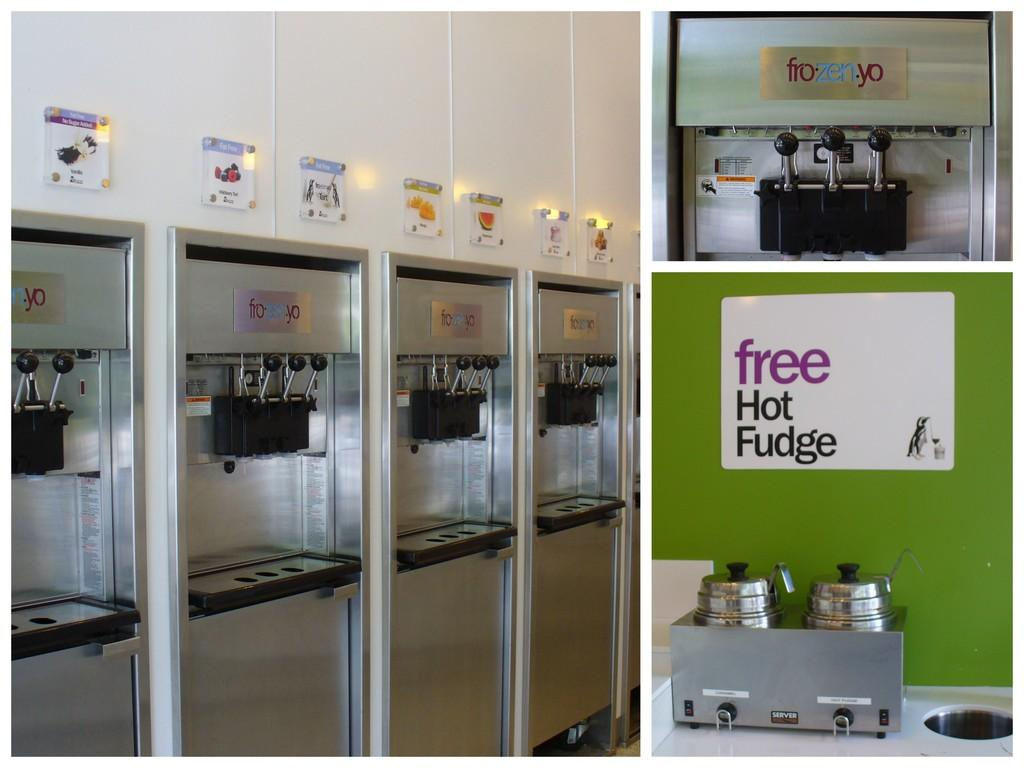Provide a one-sentence caption for the provided image. A sign at a yogurt shop advertises "free hot fudge.". 